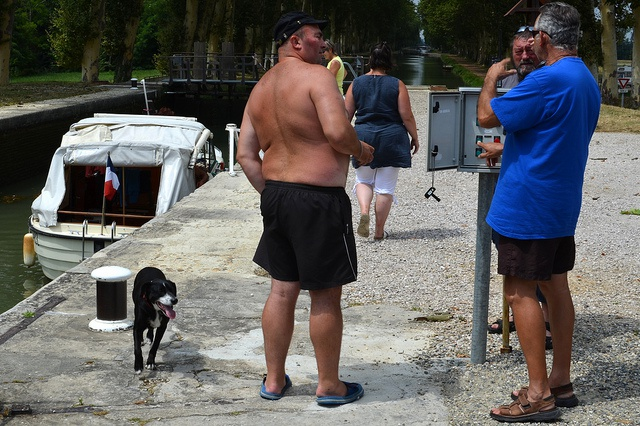Describe the objects in this image and their specific colors. I can see people in black, brown, and maroon tones, people in black, navy, maroon, and darkblue tones, boat in black, white, darkgray, and gray tones, people in black, darkgray, navy, and gray tones, and dog in black, gray, and darkgray tones in this image. 